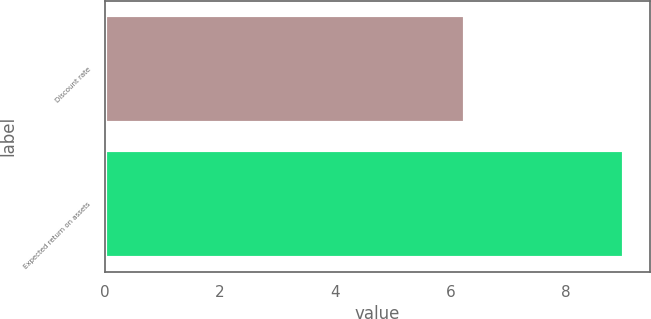Convert chart to OTSL. <chart><loc_0><loc_0><loc_500><loc_500><bar_chart><fcel>Discount rate<fcel>Expected return on assets<nl><fcel>6.25<fcel>9<nl></chart> 